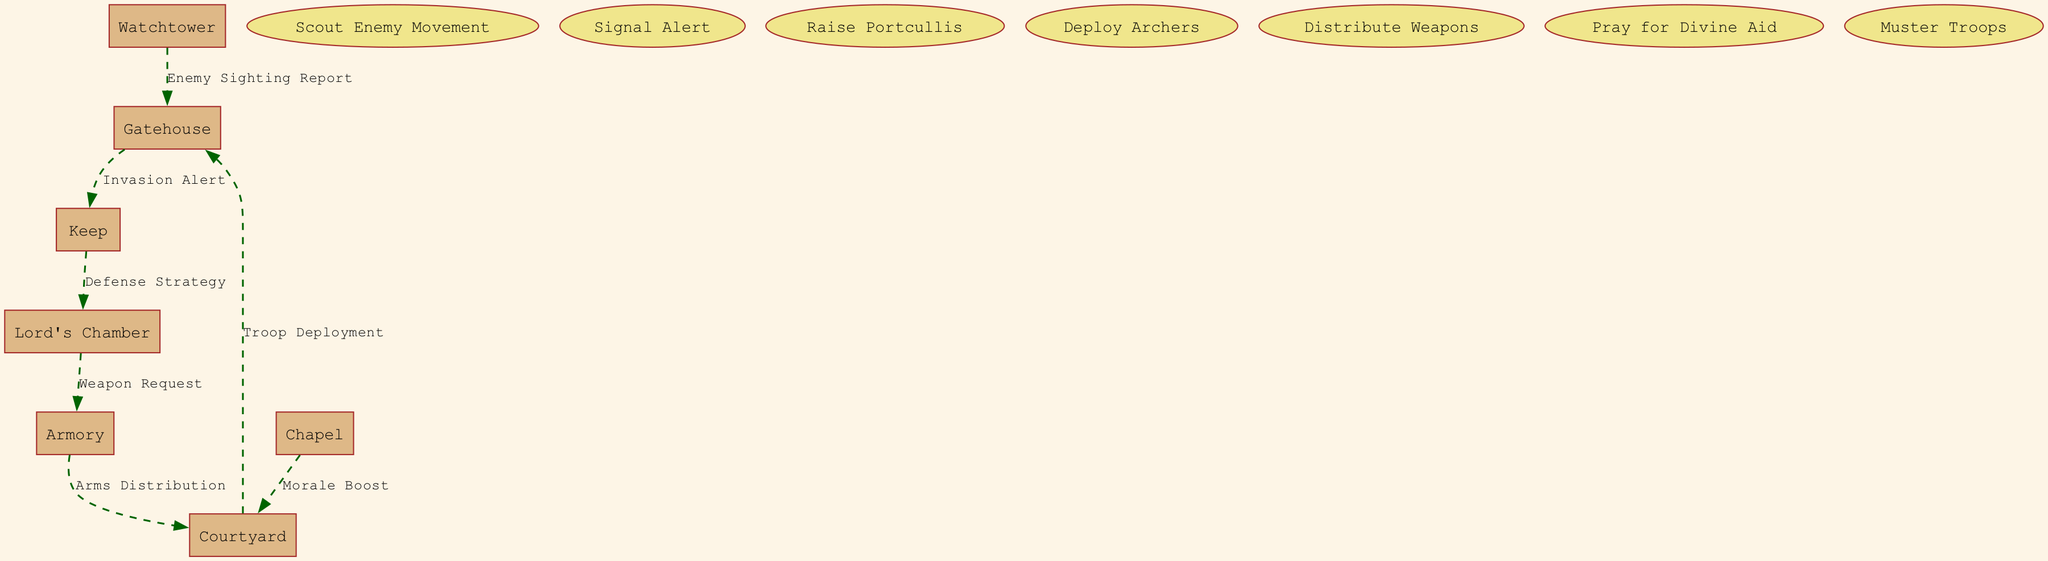What is the first entity that reports enemy movement? The diagram starts with the Watchtower as the first entity to report enemy movement through the "Enemy Sighting Report" to the Gatehouse.
Answer: Watchtower How many processes are involved in the defense system? The diagram lists a total of seven distinct processes, all of which relate to various aspects of responding to a potential invasion.
Answer: 7 Which entity receives the "Invasion Alert"? The Gatehouse is the entity that receives the "Invasion Alert" from the Watchtower after an enemy sighting.
Answer: Keep What is the relationship between the Lord's Chamber and the Armory? The relationship involves a "Weapon Request" going from the Lord's Chamber to the Armory, indicating that the Lord communicates his need for weapons to the Armory.
Answer: Weapon Request What flows from the Chapel to the Courtyard? The data flow from the Chapel to the Courtyard conveys a "Morale Boost," which signifies an effort to uplift the troops' spirits before they engage in battle.
Answer: Morale Boost What process occurs immediately after raising the portcullis? After raising the portcullis, the next step involves "Troop Deployment," where soldiers are organized in the Courtyard to prepare for defense.
Answer: Troop Deployment How many edges connect the entities and processes in the diagram? The diagram has a total of six edges connecting the distinct entities and processes together, defining the flow of information and actions.
Answer: 6 Which entity is the final destination for arms distribution? The diagram indicates that the final destination for arms distribution is the Courtyard, where the soldiers receive the arms necessary for defense.
Answer: Courtyard What is the last step in the defense process according to the diagram? The last step in the defense process, as indicated by the data flows, involves "Troop Deployment," where troops are sent out to defend the castle.
Answer: Troop Deployment 